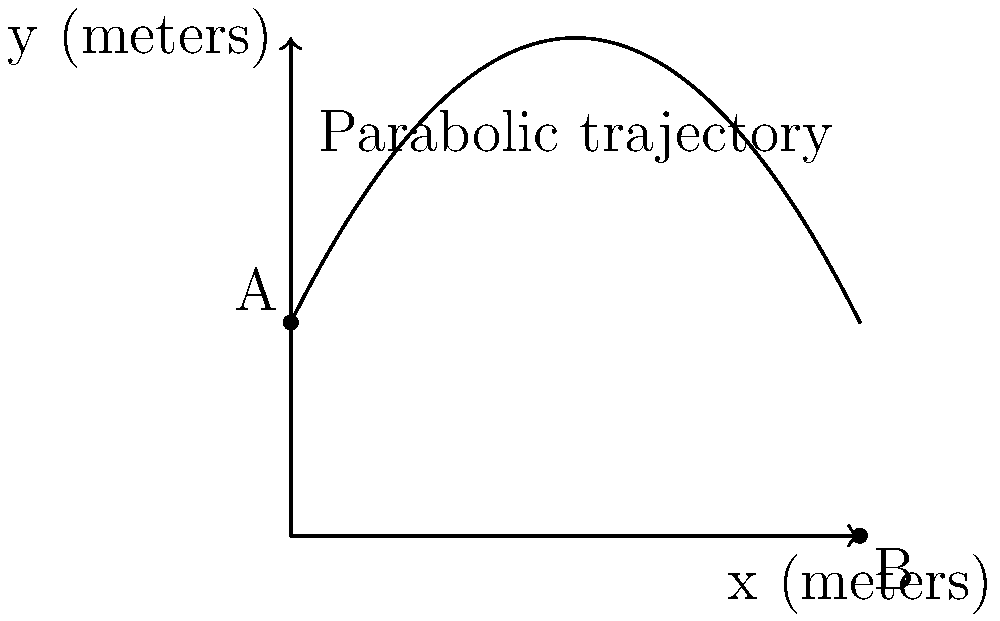A Brisbane Lions player kicks a football, and its trajectory follows the parabolic path shown in the graph. The path can be described by the function $f(x) = -0.25x^2 + 2x + 3$, where $x$ is the horizontal distance in meters and $f(x)$ is the height in meters. At what horizontal distance does the football reach its maximum height? To find the horizontal distance where the football reaches its maximum height, we need to follow these steps:

1) The maximum height of a parabola occurs at the vertex of the parabola.

2) For a quadratic function in the form $f(x) = ax^2 + bx + c$, the x-coordinate of the vertex is given by $x = -\frac{b}{2a}$.

3) In our function $f(x) = -0.25x^2 + 2x + 3$:
   $a = -0.25$
   $b = 2$
   $c = 3$

4) Plugging these values into the formula:
   $x = -\frac{b}{2a} = -\frac{2}{2(-0.25)} = -\frac{2}{-0.5} = 4$

5) Therefore, the maximum height is reached when $x = 4$ meters.

This approach uses calculus concepts without explicitly mentioning derivatives, making it suitable for high school level students. It also relates to the path of a football kick, which would appeal to a Brisbane Lions fan.
Answer: 4 meters 